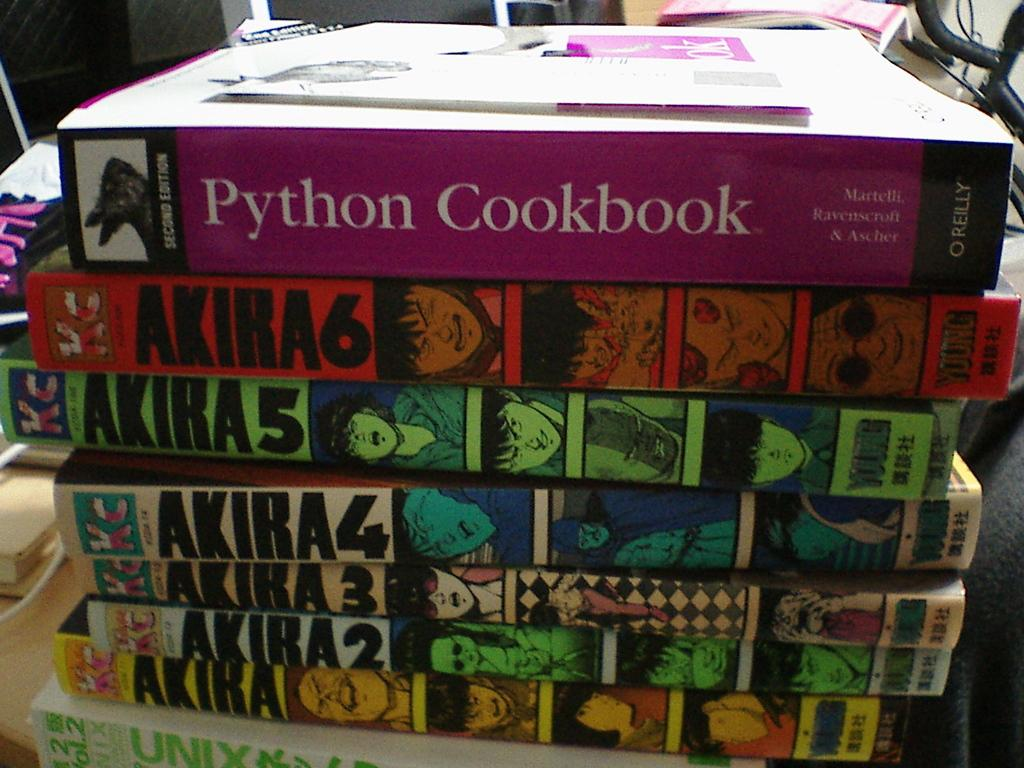<image>
Write a terse but informative summary of the picture. A collection of Akira books as well as a Python Cookbook. 